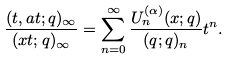Convert formula to latex. <formula><loc_0><loc_0><loc_500><loc_500>\frac { ( t , a t ; q ) _ { \infty } } { ( x t ; q ) _ { \infty } } = \sum _ { n = 0 } ^ { \infty } \frac { U _ { n } ^ { ( \alpha ) } ( x ; q ) } { ( q ; q ) _ { n } } t ^ { n } .</formula> 